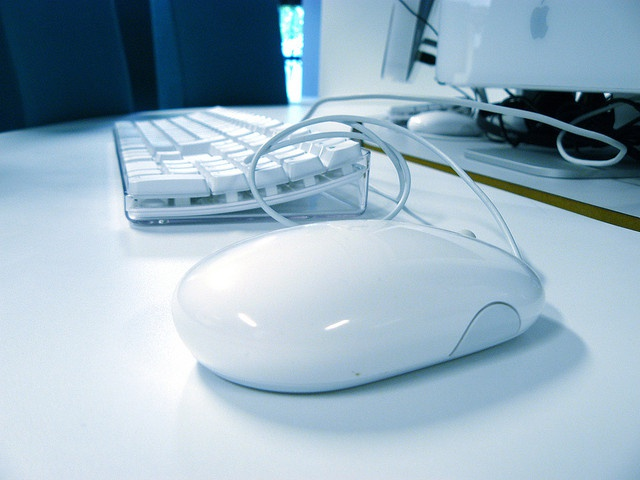Describe the objects in this image and their specific colors. I can see mouse in navy, lightgray, lightblue, and darkgray tones, keyboard in navy, white, lightblue, and gray tones, tv in navy, lightblue, and darkgray tones, and mouse in navy, gray, blue, lightgray, and lightblue tones in this image. 